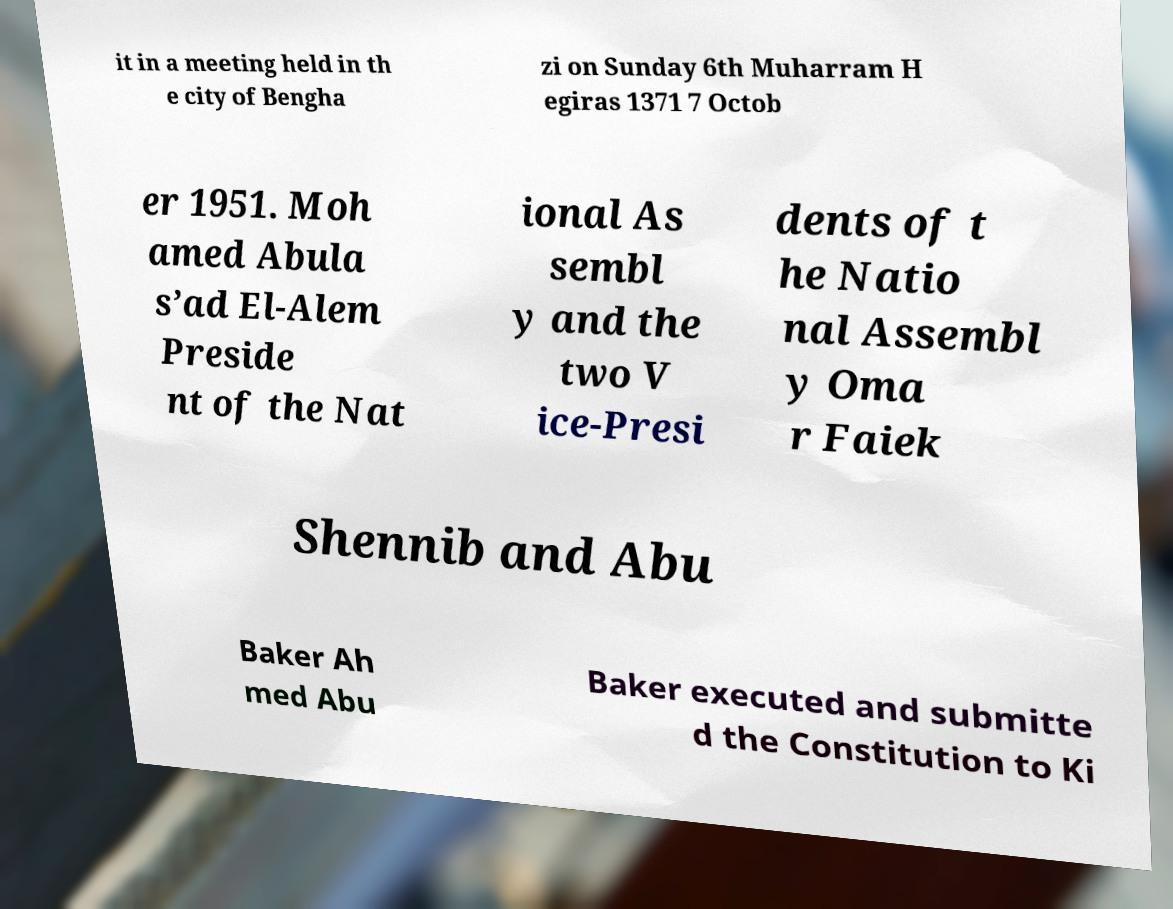Please identify and transcribe the text found in this image. it in a meeting held in th e city of Bengha zi on Sunday 6th Muharram H egiras 1371 7 Octob er 1951. Moh amed Abula s’ad El-Alem Preside nt of the Nat ional As sembl y and the two V ice-Presi dents of t he Natio nal Assembl y Oma r Faiek Shennib and Abu Baker Ah med Abu Baker executed and submitte d the Constitution to Ki 